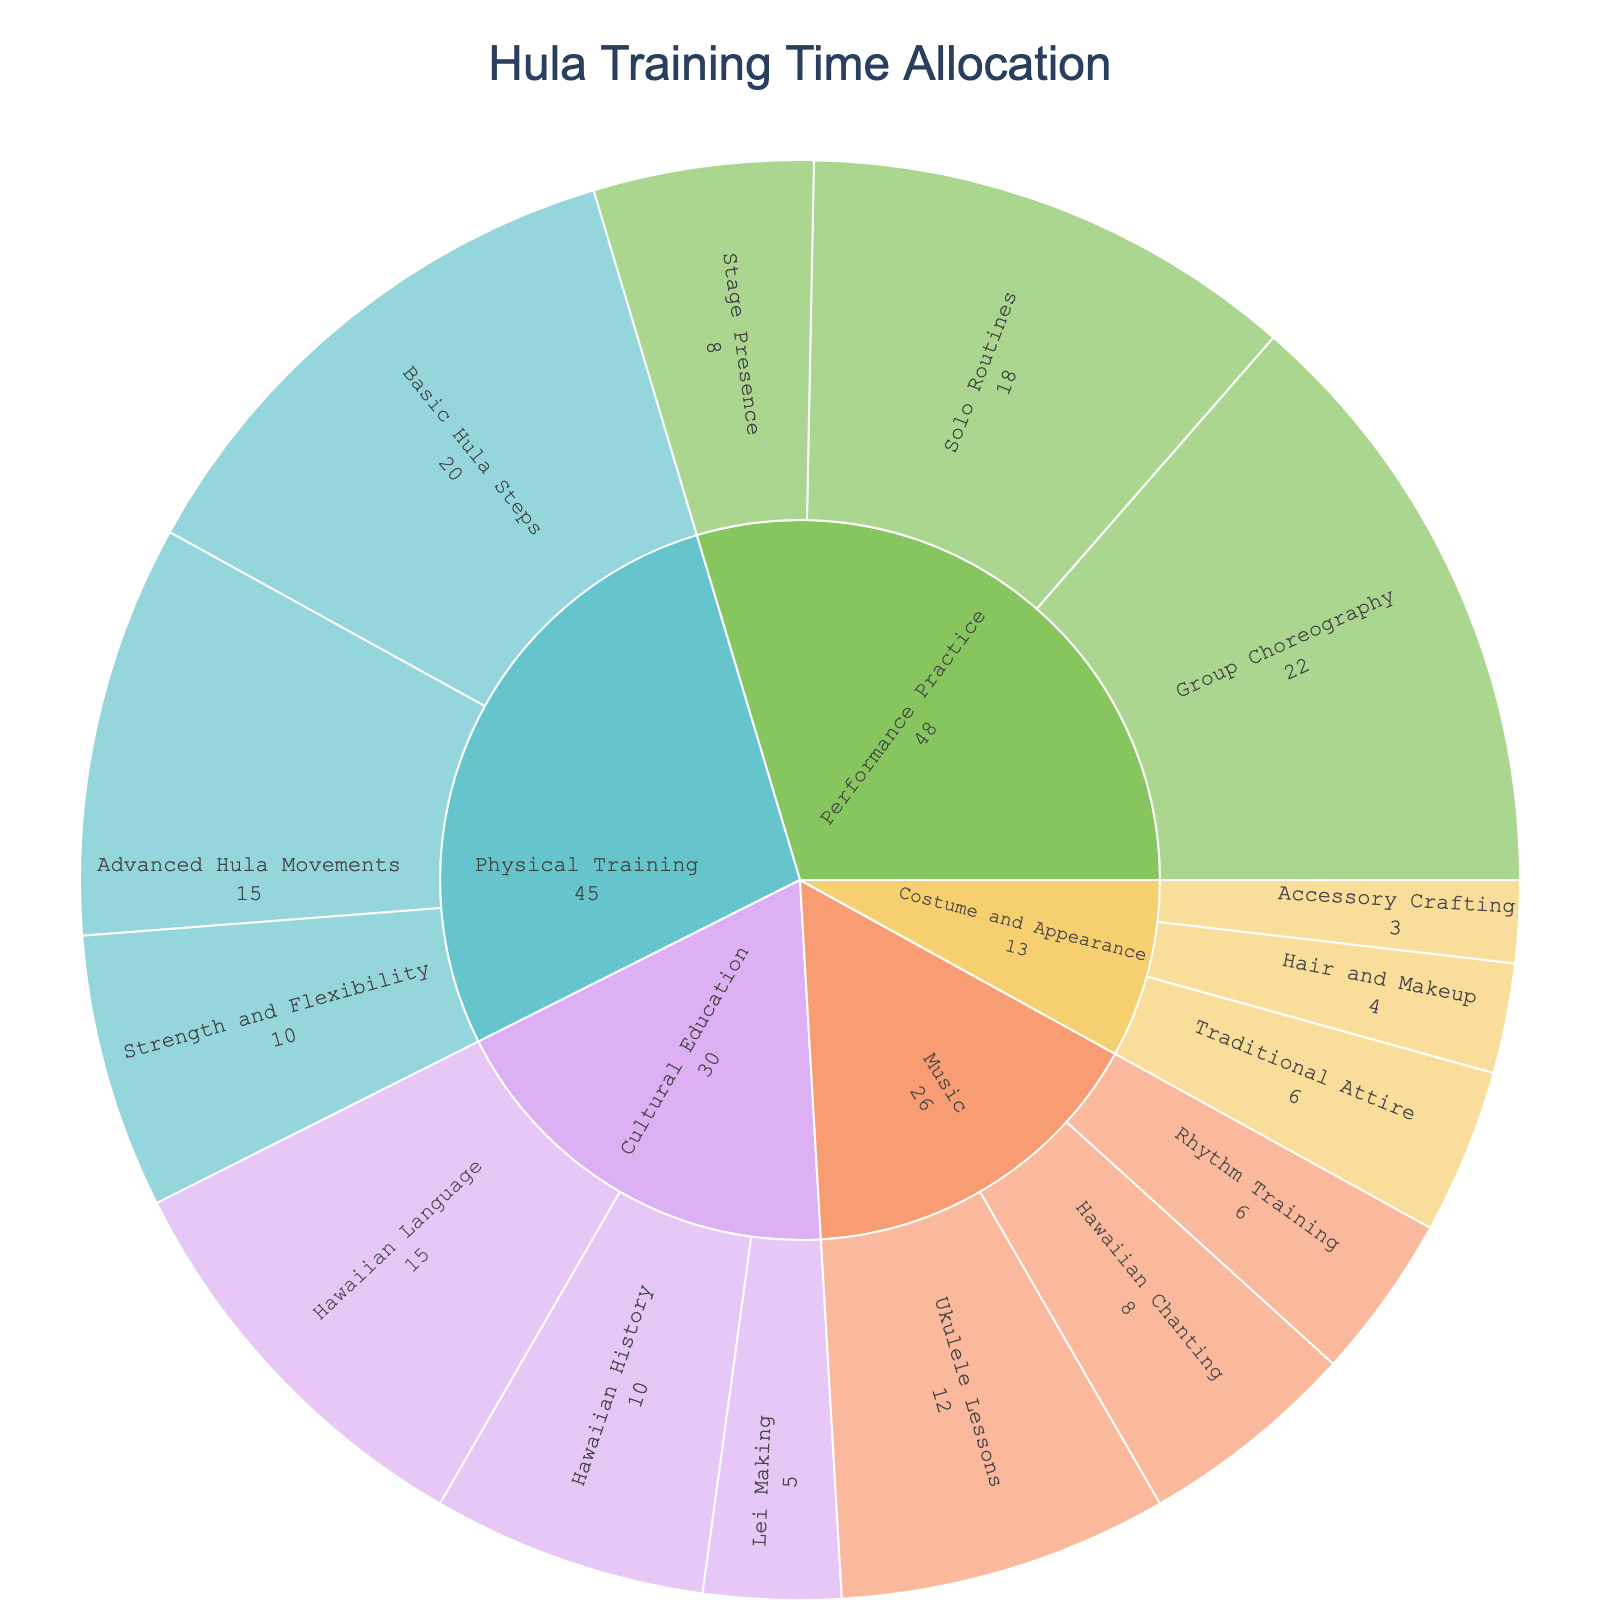What is the title of the plot? The title is usually placed at the top of the plot and often has a larger font size.
Answer: Hula Training Time Allocation Which category has the highest total hours allocated? Identify which outer segment covers the largest area. This will indicate the category with the highest total hours.
Answer: Performance Practice How many hours are allocated to Hawaiian Chanting? Find Hawaiian Chanting within the Music segment and read the hours.
Answer: 8 Which subcategory under Cultural Education has the least number of hours? Look at the subcategories under Cultural Education and find the one with the smallest segment.
Answer: Lei Making What is the total number of hours allocated to Physical Training? Add the hours from all subcategories under Physical Training: 20 + 15 + 10.
Answer: 45 Compare the hours allocated to Group Choreography and Solo Routines in Performance Practice. Which one has more hours? Refer to the subcategories under Performance Practice and compare their hours.
Answer: Group Choreography What's the total number of hours devoted to Costume and Appearance? Sum the hours of Traditional Attire, Hair and Makeup, and Accessory Crafting under Costume and Appearance: 6 + 4 + 3.
Answer: 13 Which subcategory has more hours: Ukulele Lessons or Hawaiian Language? Compare the hours between Ukulele Lessons under Music and Hawaiian Language under Cultural Education.
Answer: Hawaiian Language Are there more hours allocated to Advanced Hula Movements or Stage Presence? Compare the hours of Advanced Hula Movements under Physical Training with Stage Presence under Performance Practice.
Answer: Advanced Hula Movements What is the average number of hours allocated to subcategories under Music? Add the hours and divide by the number of subcategories: (12 + 8 + 6) / 3.
Answer: 8.67 